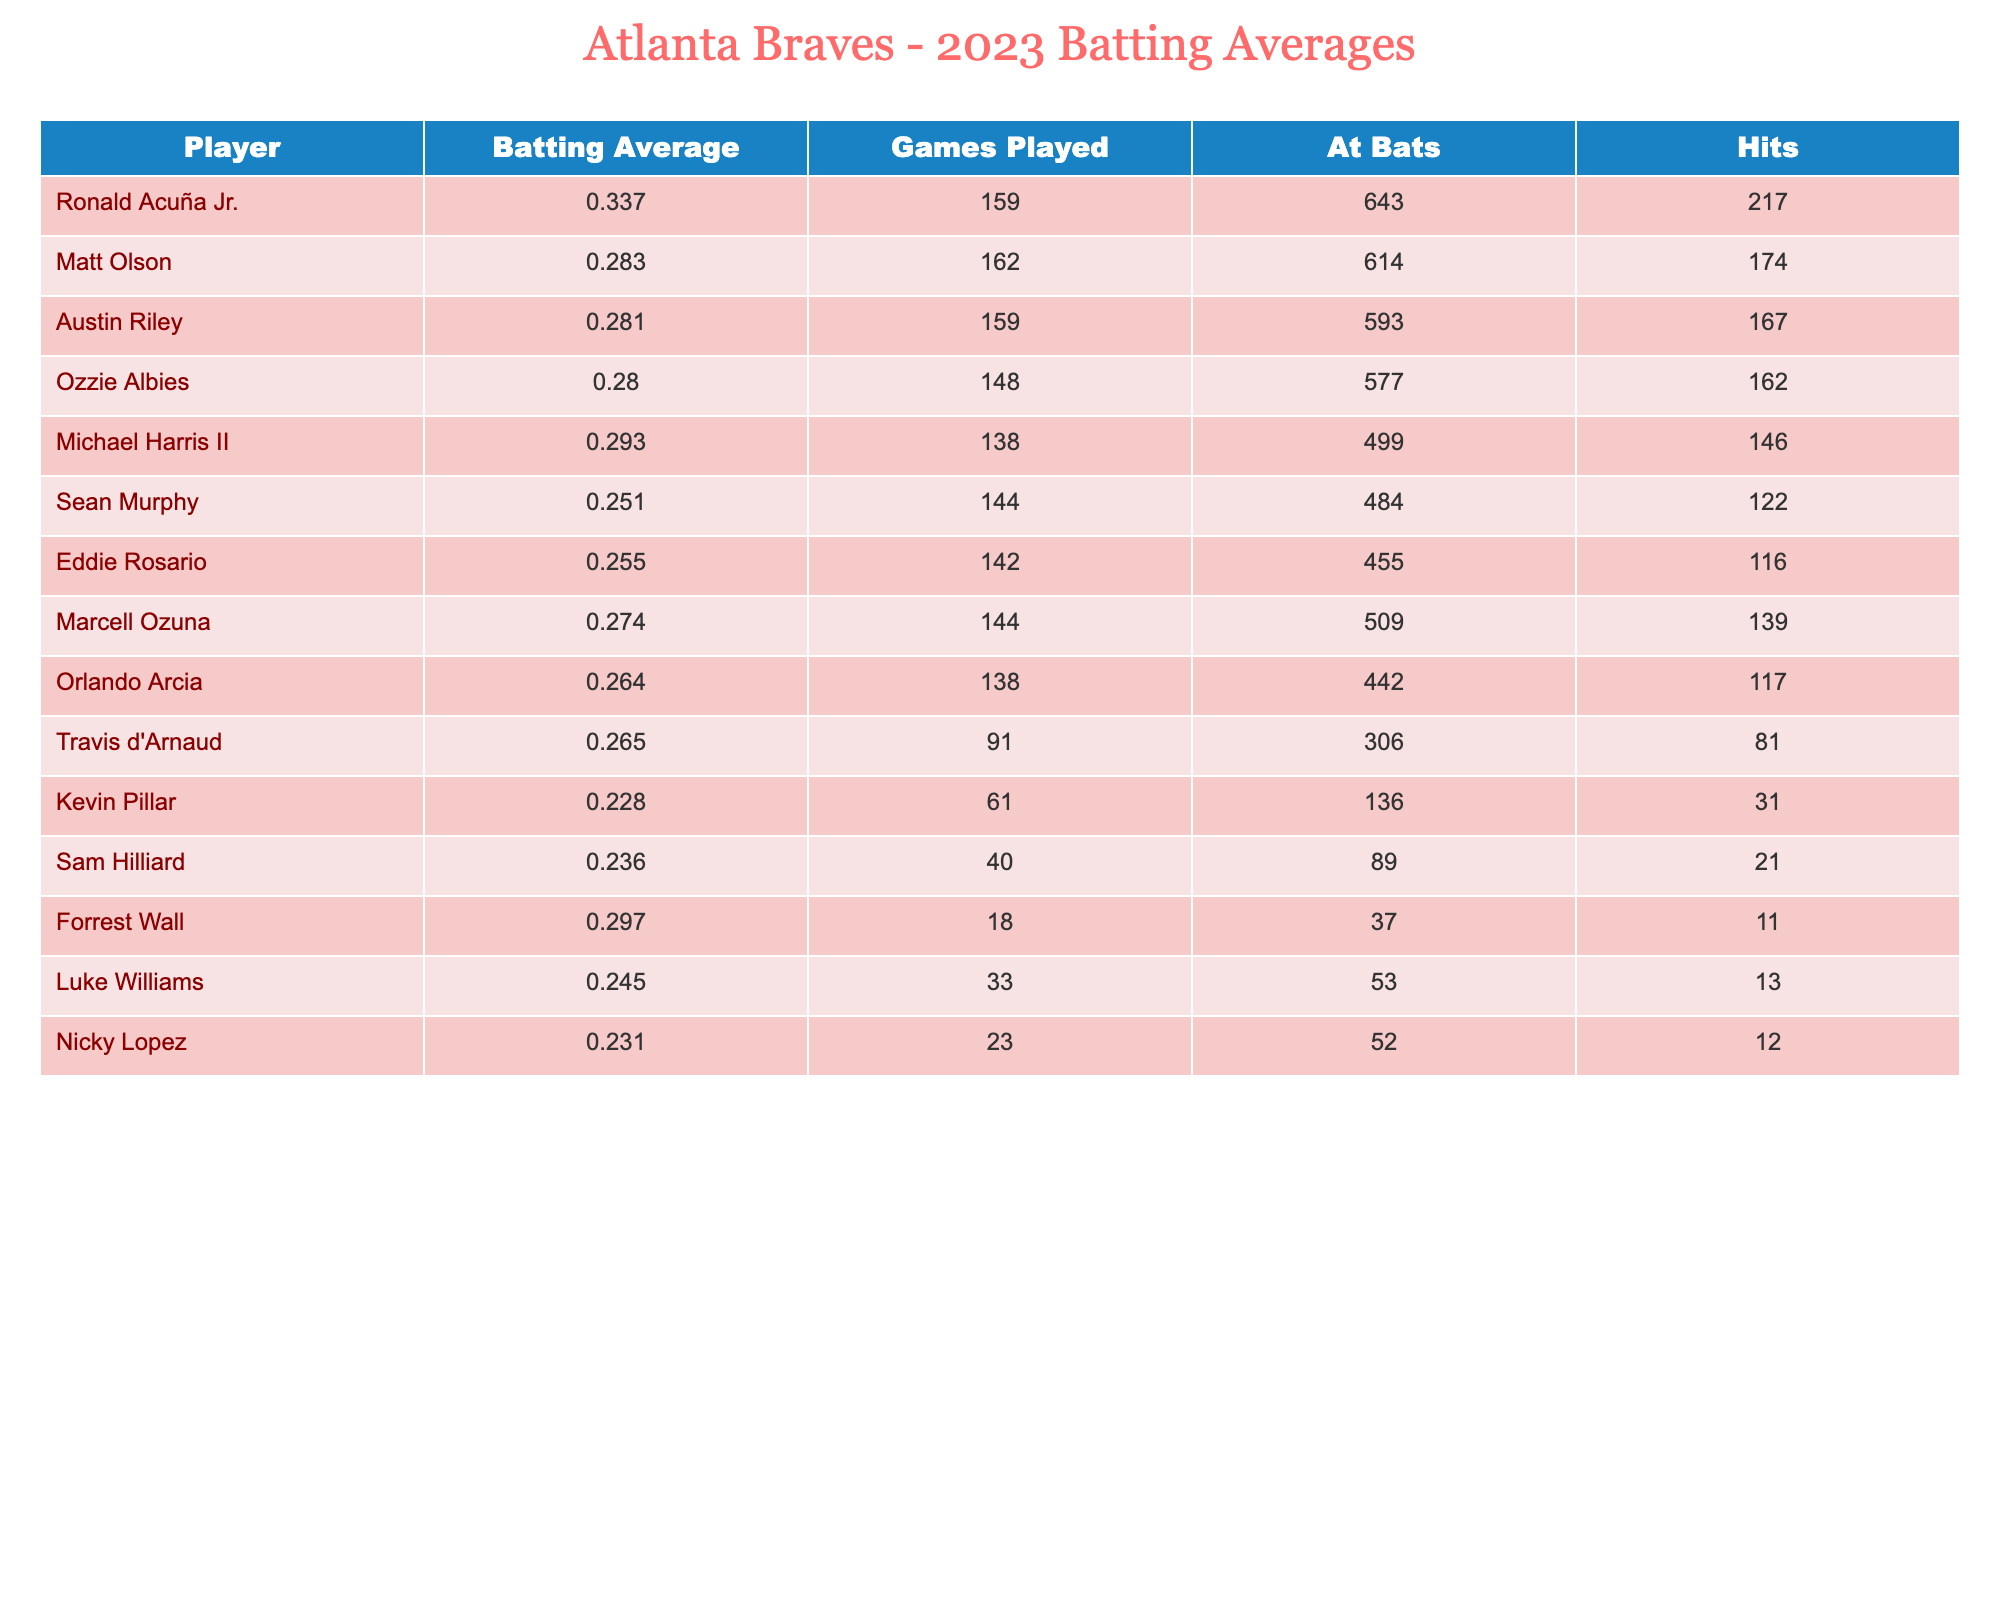What is the batting average of Ronald Acuña Jr.? According to the table, Ronald Acuña Jr.'s batting average is listed directly, which is .337.
Answer: .337 Who played the most games among the listed players? By examining the "Games Played" column, the highest value is 162, which belongs to Matt Olson.
Answer: Matt Olson What is the combined total of hits for Austin Riley and Ozzie Albies? Adding the hits: Austin Riley has 167 hits and Ozzie Albies has 162 hits. So, 167 + 162 = 329.
Answer: 329 Does Sean Murphy have a batting average over .250? The table shows Sean Murphy's batting average as .251, which is indeed above .250.
Answer: Yes Which player has the lowest batting average? By looking at the "Batting Average" column, Kevin Pillar has the lowest value listed at .228.
Answer: Kevin Pillar What is the average batting average of the top three players? The top three are Ronald Acuña Jr. (.337), Matt Olson (.283), and Austin Riley (.281). To calculate the average: (0.337 + 0.283 + 0.281) / 3 = 0.300
Answer: .300 How many players have batting averages below .250? Counting the players with averages below .250, we see Sean Murphy, Eddie Rosario, Kevin Pillar, and Sam Hilliard, totaling four players.
Answer: 4 Is there any player with more than 200 hits? Checking the hits column, Ronald Acuña Jr. has 217 hits, which is more than 200.
Answer: Yes What is the difference in batting average between Michael Harris II and Marcell Ozuna? Michael Harris II has .293 and Marcell Ozuna has .274. The difference is calculated as .293 - .274 = .019.
Answer: .019 Which player has a batting average closest to .250 without going below it? By checking the averages, Sean Murphy at .251 is the closest to .250 while still being above it.
Answer: Sean Murphy 